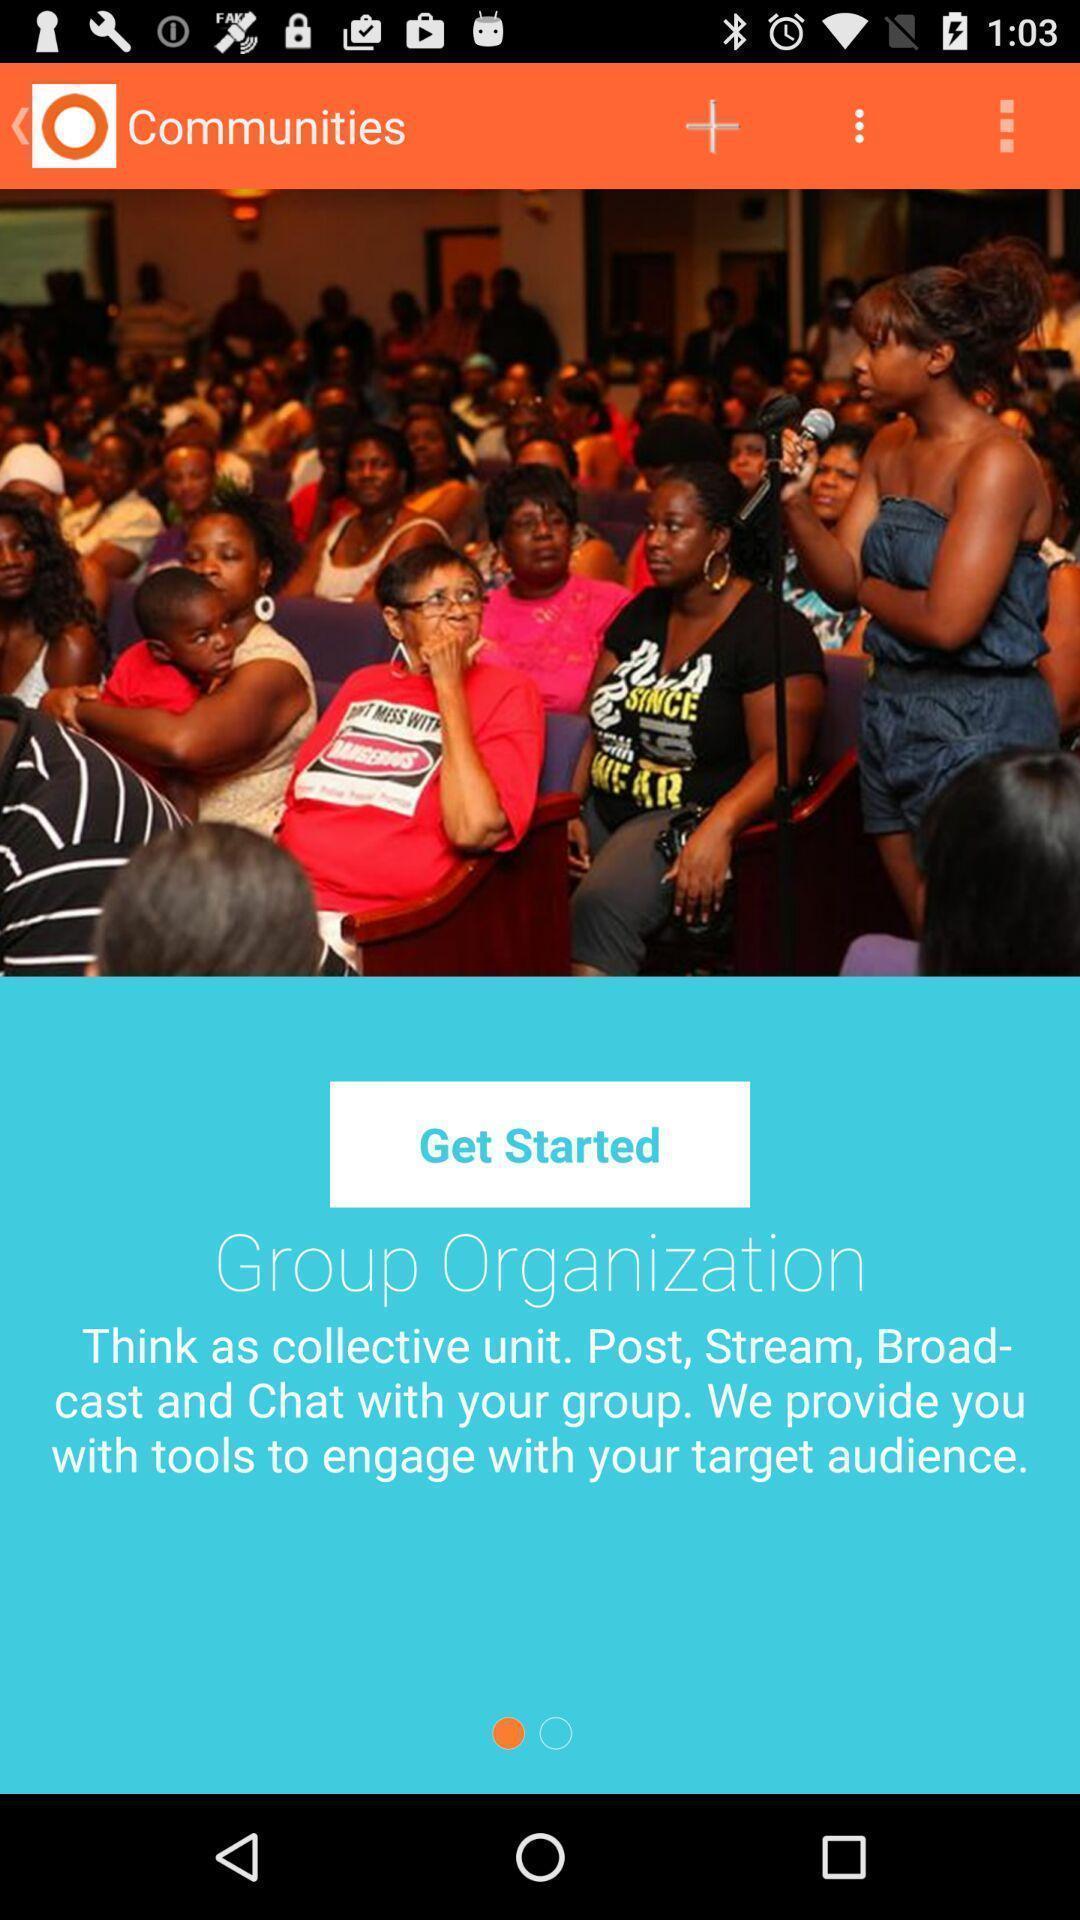Describe this image in words. Welcome page. 